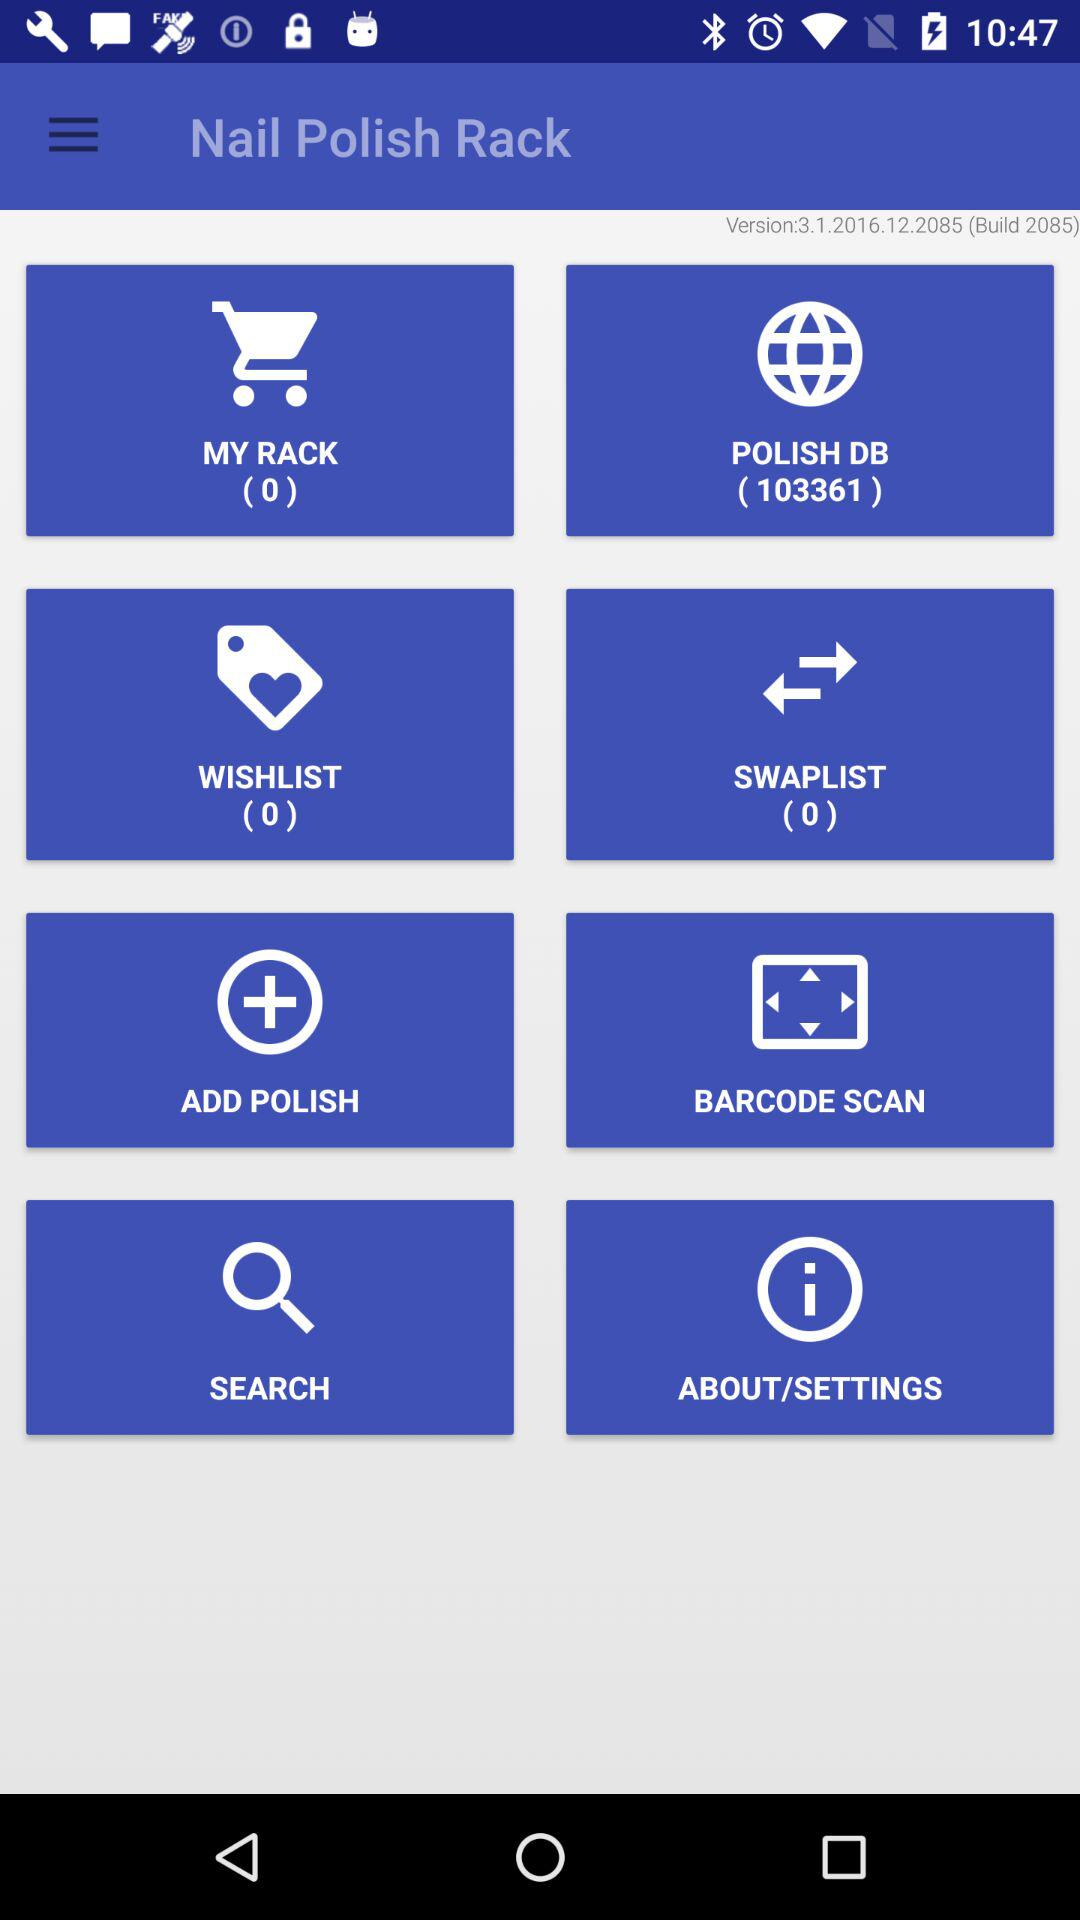What is the count of "MY RACK"? The count of "MY RACK" is 0. 